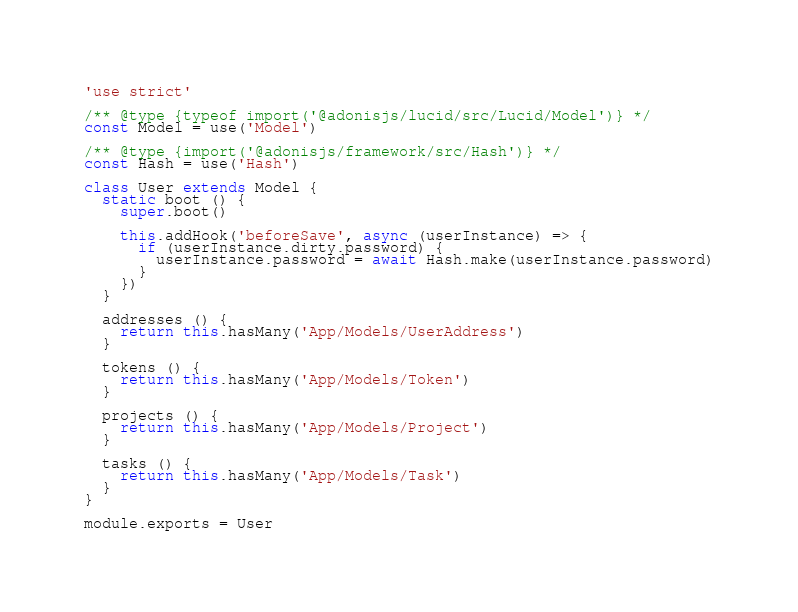<code> <loc_0><loc_0><loc_500><loc_500><_JavaScript_>'use strict'

/** @type {typeof import('@adonisjs/lucid/src/Lucid/Model')} */
const Model = use('Model')

/** @type {import('@adonisjs/framework/src/Hash')} */
const Hash = use('Hash')

class User extends Model {
  static boot () {
    super.boot()

    this.addHook('beforeSave', async (userInstance) => {
      if (userInstance.dirty.password) {
        userInstance.password = await Hash.make(userInstance.password)
      }
    })
  }

  addresses () {
    return this.hasMany('App/Models/UserAddress')
  }

  tokens () {
    return this.hasMany('App/Models/Token')
  }

  projects () {
    return this.hasMany('App/Models/Project')
  }

  tasks () {
    return this.hasMany('App/Models/Task')
  }
}

module.exports = User
</code> 